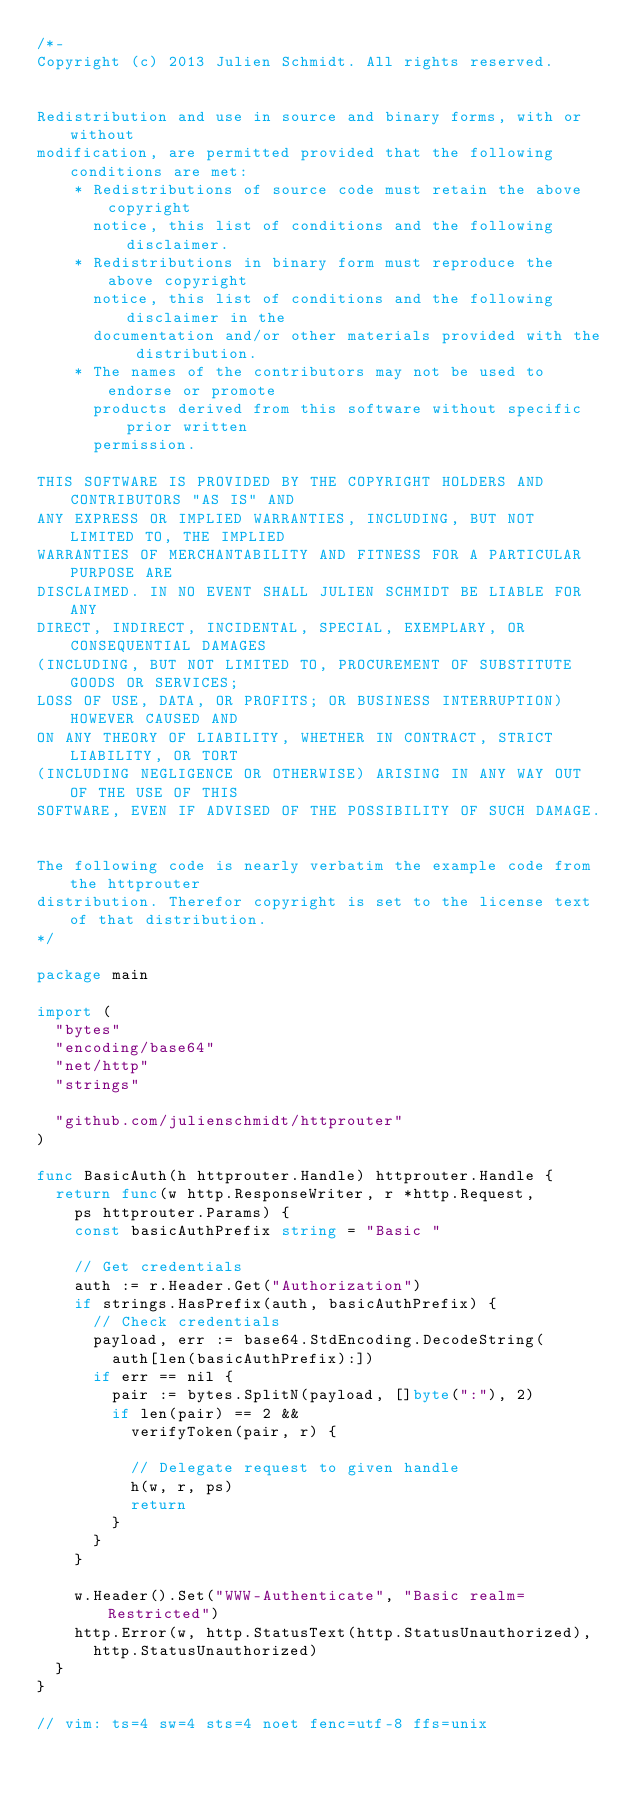<code> <loc_0><loc_0><loc_500><loc_500><_Go_>/*-
Copyright (c) 2013 Julien Schmidt. All rights reserved.


Redistribution and use in source and binary forms, with or without
modification, are permitted provided that the following conditions are met:
    * Redistributions of source code must retain the above copyright
      notice, this list of conditions and the following disclaimer.
    * Redistributions in binary form must reproduce the above copyright
      notice, this list of conditions and the following disclaimer in the
      documentation and/or other materials provided with the distribution.
    * The names of the contributors may not be used to endorse or promote
      products derived from this software without specific prior written
      permission.

THIS SOFTWARE IS PROVIDED BY THE COPYRIGHT HOLDERS AND CONTRIBUTORS "AS IS" AND
ANY EXPRESS OR IMPLIED WARRANTIES, INCLUDING, BUT NOT LIMITED TO, THE IMPLIED
WARRANTIES OF MERCHANTABILITY AND FITNESS FOR A PARTICULAR PURPOSE ARE
DISCLAIMED. IN NO EVENT SHALL JULIEN SCHMIDT BE LIABLE FOR ANY
DIRECT, INDIRECT, INCIDENTAL, SPECIAL, EXEMPLARY, OR CONSEQUENTIAL DAMAGES
(INCLUDING, BUT NOT LIMITED TO, PROCUREMENT OF SUBSTITUTE GOODS OR SERVICES;
LOSS OF USE, DATA, OR PROFITS; OR BUSINESS INTERRUPTION) HOWEVER CAUSED AND
ON ANY THEORY OF LIABILITY, WHETHER IN CONTRACT, STRICT LIABILITY, OR TORT
(INCLUDING NEGLIGENCE OR OTHERWISE) ARISING IN ANY WAY OUT OF THE USE OF THIS
SOFTWARE, EVEN IF ADVISED OF THE POSSIBILITY OF SUCH DAMAGE.


The following code is nearly verbatim the example code from the httprouter
distribution. Therefor copyright is set to the license text of that distribution.
*/

package main

import (
	"bytes"
	"encoding/base64"
	"net/http"
	"strings"

	"github.com/julienschmidt/httprouter"
)

func BasicAuth(h httprouter.Handle) httprouter.Handle {
	return func(w http.ResponseWriter, r *http.Request,
		ps httprouter.Params) {
		const basicAuthPrefix string = "Basic "

		// Get credentials
		auth := r.Header.Get("Authorization")
		if strings.HasPrefix(auth, basicAuthPrefix) {
			// Check credentials
			payload, err := base64.StdEncoding.DecodeString(
				auth[len(basicAuthPrefix):])
			if err == nil {
				pair := bytes.SplitN(payload, []byte(":"), 2)
				if len(pair) == 2 &&
					verifyToken(pair, r) {

					// Delegate request to given handle
					h(w, r, ps)
					return
				}
			}
		}

		w.Header().Set("WWW-Authenticate", "Basic realm=Restricted")
		http.Error(w, http.StatusText(http.StatusUnauthorized),
			http.StatusUnauthorized)
	}
}

// vim: ts=4 sw=4 sts=4 noet fenc=utf-8 ffs=unix
</code> 